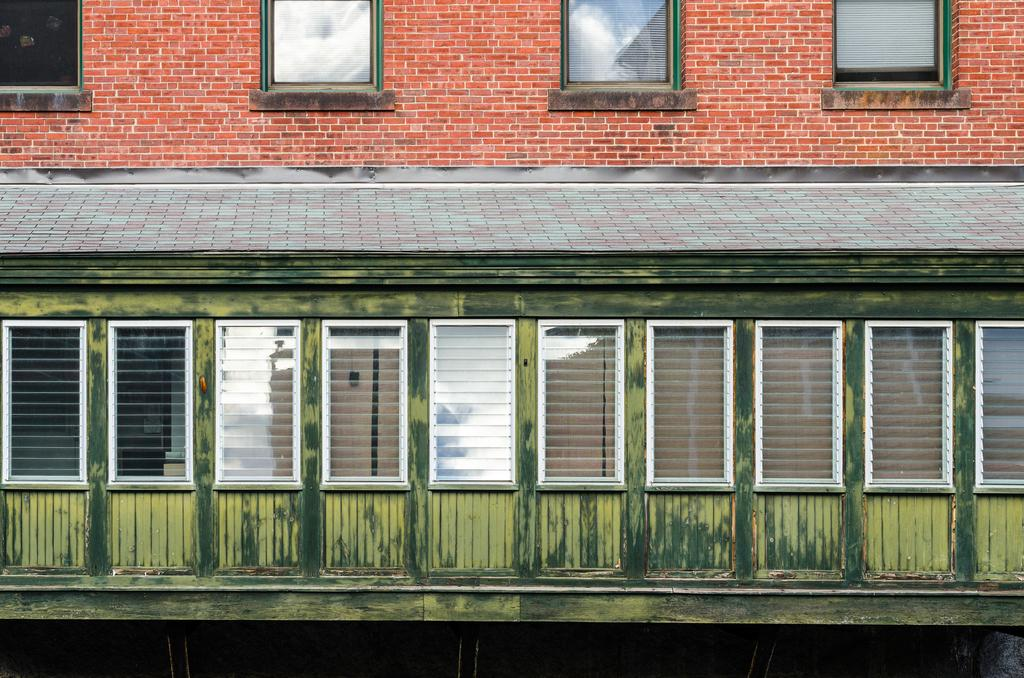What type of structure is in the picture? There is a building in the picture. What features can be seen on the building? The building has windows, curtains, and a brick wall. What type of insurance policy is being discussed in the picture? There is no discussion of insurance policies in the picture; it features a building with windows, curtains, and a brick wall. 